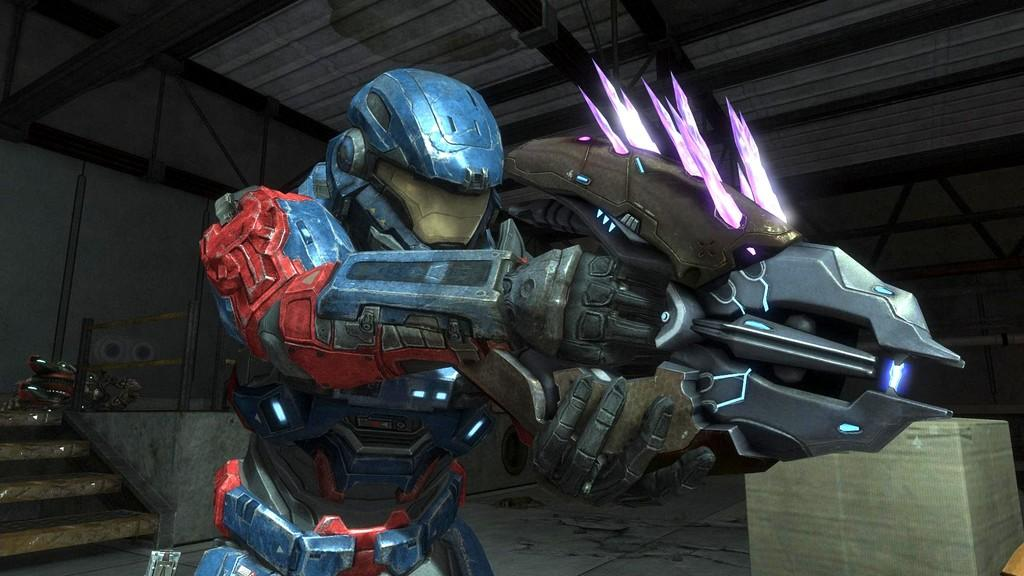What is the main subject in the middle of the image? There is a robot in the middle of the image. What can be seen in the background of the image? There is a wall in the background of the image. Can you describe the object in the bottom right corner of the image? Unfortunately, the facts provided do not give any information about the object in the bottom right corner of the image. How many chickens are sitting on the robot in the image? There are no chickens present in the image. What type of oven is visible in the background of the image? There is no oven present in the image; it only features a robot and a wall in the background. 